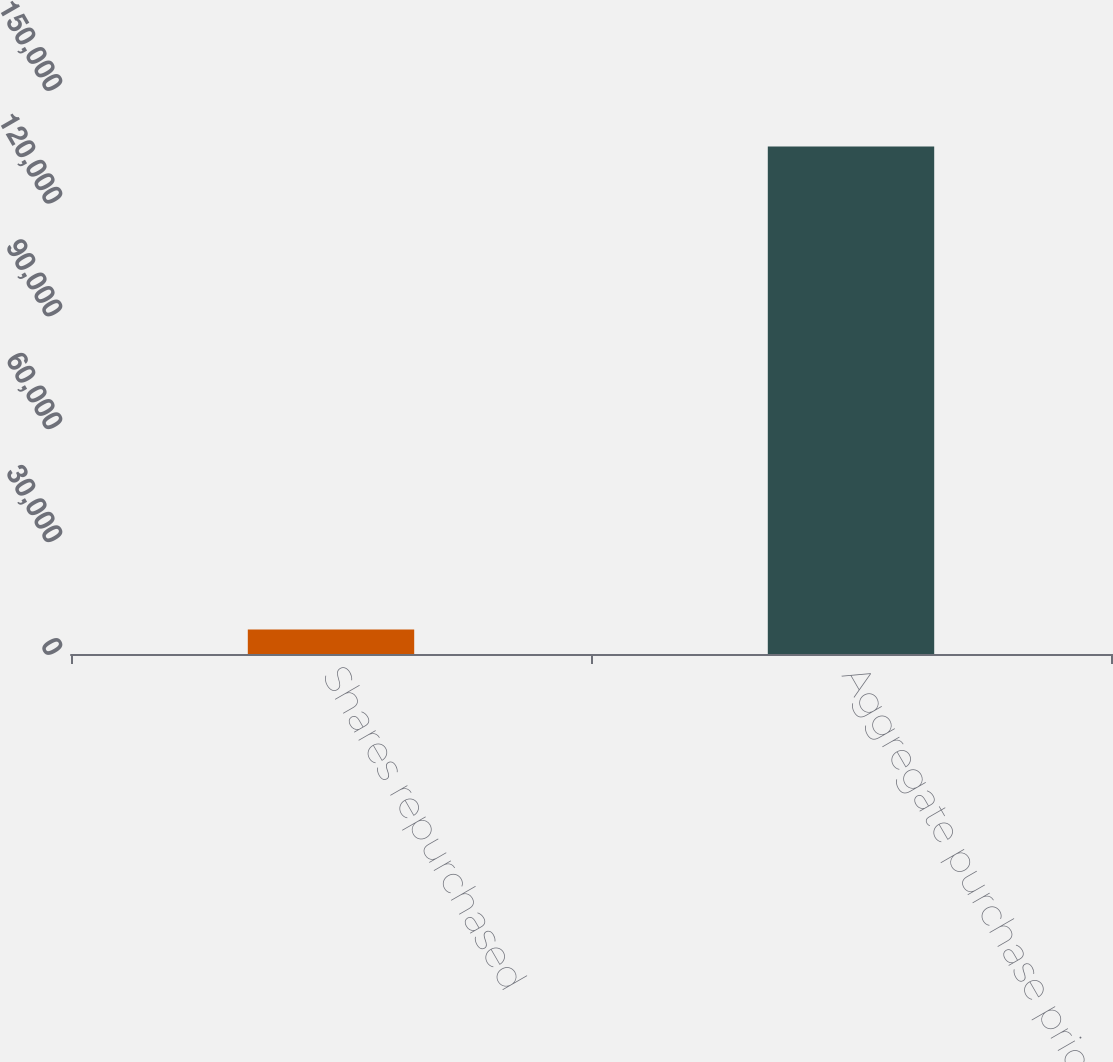Convert chart. <chart><loc_0><loc_0><loc_500><loc_500><bar_chart><fcel>Shares repurchased<fcel>Aggregate purchase price<nl><fcel>6490<fcel>135000<nl></chart> 